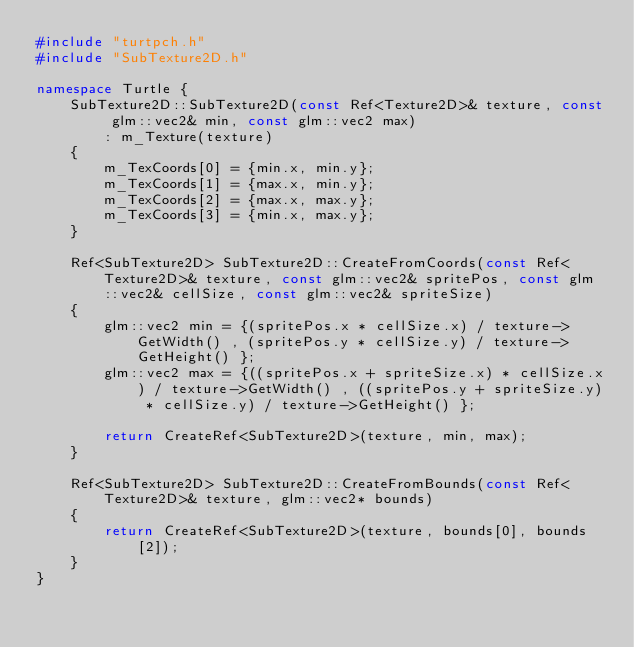<code> <loc_0><loc_0><loc_500><loc_500><_C++_>#include "turtpch.h"
#include "SubTexture2D.h"

namespace Turtle {
	SubTexture2D::SubTexture2D(const Ref<Texture2D>& texture, const glm::vec2& min, const glm::vec2 max)
		: m_Texture(texture)
	{
		m_TexCoords[0] = {min.x, min.y};
		m_TexCoords[1] = {max.x, min.y};
		m_TexCoords[2] = {max.x, max.y};
		m_TexCoords[3] = {min.x, max.y};
	}

	Ref<SubTexture2D> SubTexture2D::CreateFromCoords(const Ref<Texture2D>& texture, const glm::vec2& spritePos, const glm::vec2& cellSize, const glm::vec2& spriteSize)
	{
		glm::vec2 min = {(spritePos.x * cellSize.x) / texture->GetWidth() , (spritePos.y * cellSize.y) / texture->GetHeight() };
		glm::vec2 max = {((spritePos.x + spriteSize.x) * cellSize.x) / texture->GetWidth() , ((spritePos.y + spriteSize.y) * cellSize.y) / texture->GetHeight() };
		
		return CreateRef<SubTexture2D>(texture, min, max);	
	}

	Ref<SubTexture2D> SubTexture2D::CreateFromBounds(const Ref<Texture2D>& texture, glm::vec2* bounds)
	{
		return CreateRef<SubTexture2D>(texture, bounds[0], bounds[2]);	
	}
}</code> 